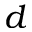<formula> <loc_0><loc_0><loc_500><loc_500>d</formula> 